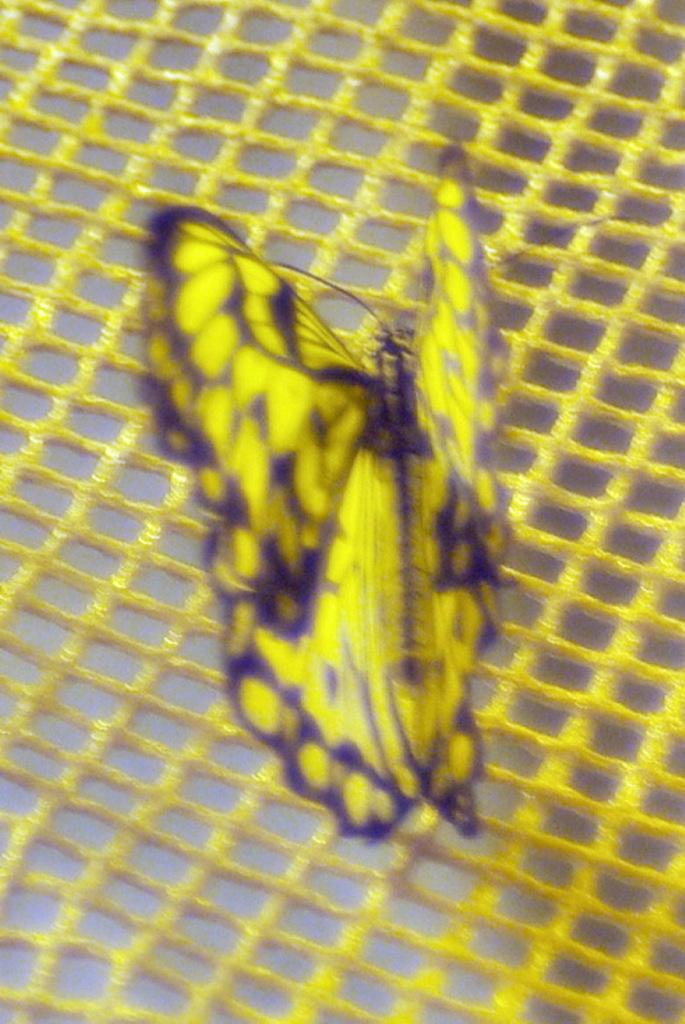What is the main subject of the image? The main subject of the image is a butterfly. Can you describe the colors of the butterfly? The butterfly is yellow and violet in color. What is the butterfly resting on in the image? The butterfly is on a yellow colored net. What color is the background of the image? The background of the image is cream colored. What type of robin can be seen inside the jar in the image? There is no robin or jar present in the image; it features a butterfly on a yellow colored net with a cream-colored background. 